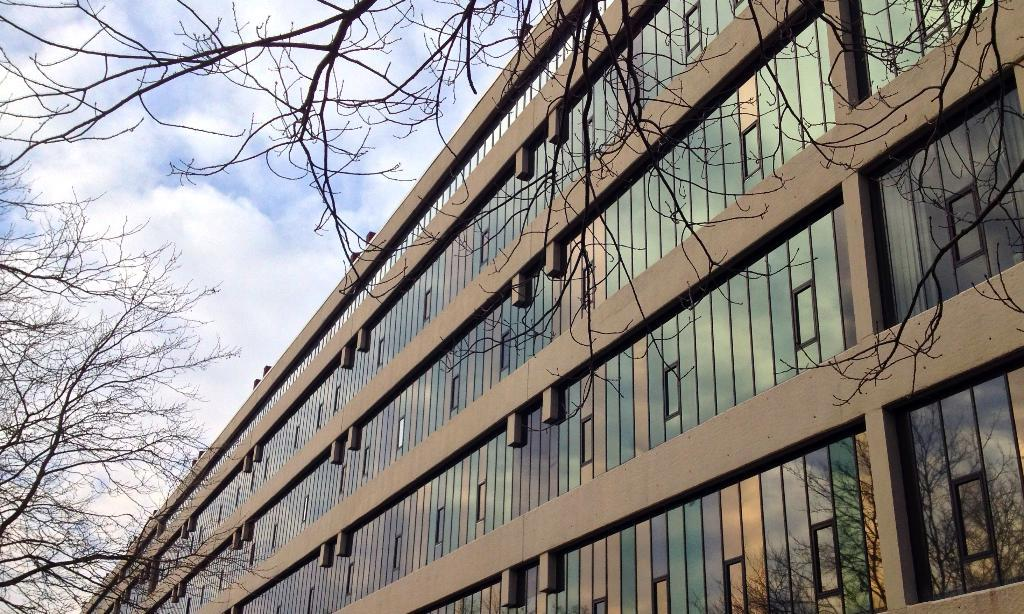What type of structure is visible in the image? There is a building in the image. What can be seen near the building? There are trees near the building. What is visible in the background of the image? The sky is visible in the background of the image. What can be observed in the sky? Clouds are present in the sky. What type of glove is hanging from the tree in the image? There is no glove present in the image; it only features a building, trees, and clouds in the sky. 